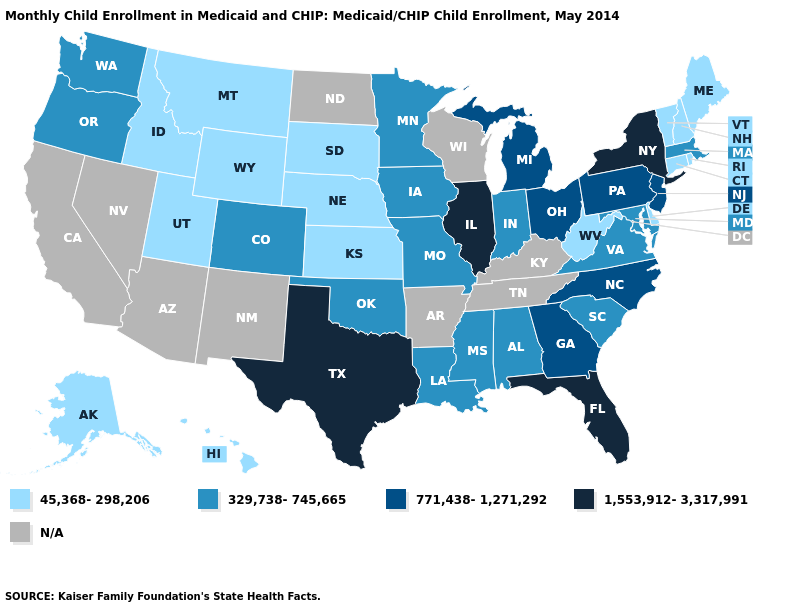Does Wyoming have the lowest value in the West?
Give a very brief answer. Yes. What is the lowest value in the USA?
Answer briefly. 45,368-298,206. What is the value of Nebraska?
Answer briefly. 45,368-298,206. Among the states that border Kansas , which have the lowest value?
Be succinct. Nebraska. What is the value of Virginia?
Keep it brief. 329,738-745,665. What is the lowest value in states that border Washington?
Be succinct. 45,368-298,206. What is the value of South Dakota?
Be succinct. 45,368-298,206. What is the lowest value in the West?
Write a very short answer. 45,368-298,206. Among the states that border Pennsylvania , which have the lowest value?
Quick response, please. Delaware, West Virginia. What is the value of Michigan?
Concise answer only. 771,438-1,271,292. Which states have the lowest value in the USA?
Concise answer only. Alaska, Connecticut, Delaware, Hawaii, Idaho, Kansas, Maine, Montana, Nebraska, New Hampshire, Rhode Island, South Dakota, Utah, Vermont, West Virginia, Wyoming. What is the highest value in states that border Montana?
Concise answer only. 45,368-298,206. Which states hav the highest value in the West?
Answer briefly. Colorado, Oregon, Washington. Does New York have the lowest value in the USA?
Short answer required. No. Name the states that have a value in the range N/A?
Keep it brief. Arizona, Arkansas, California, Kentucky, Nevada, New Mexico, North Dakota, Tennessee, Wisconsin. 